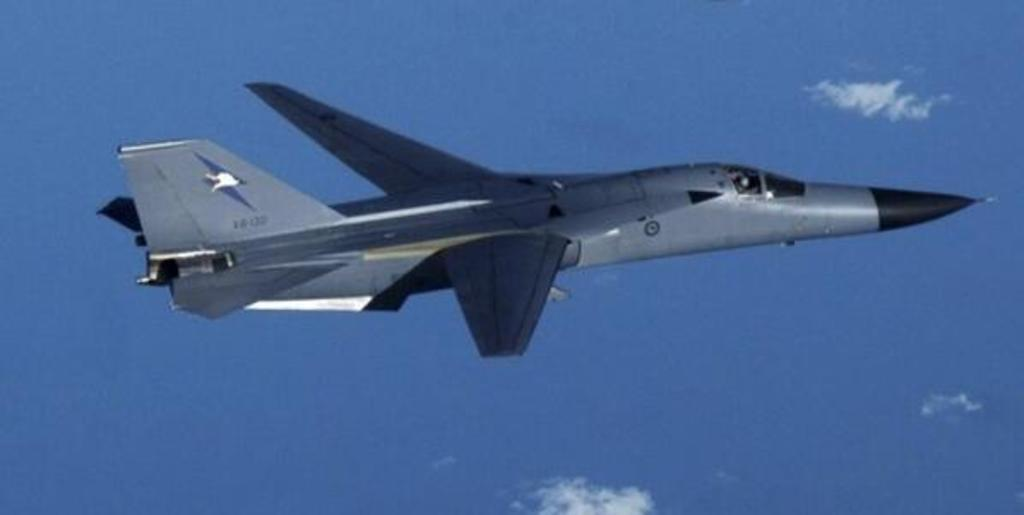What is the main subject of the image? The main subject of the image is an airplane. Can you describe the position of the airplane in the image? The airplane is in the air in the image. What can be seen in the background of the image? There is sky visible in the background of the image. What is the condition of the sky in the image? Clouds are present in the sky in the image. How many rings can be seen on the donkey's neck in the image? There is no donkey or rings present in the image. Is there a prison visible in the image? There is no prison present in the image. 